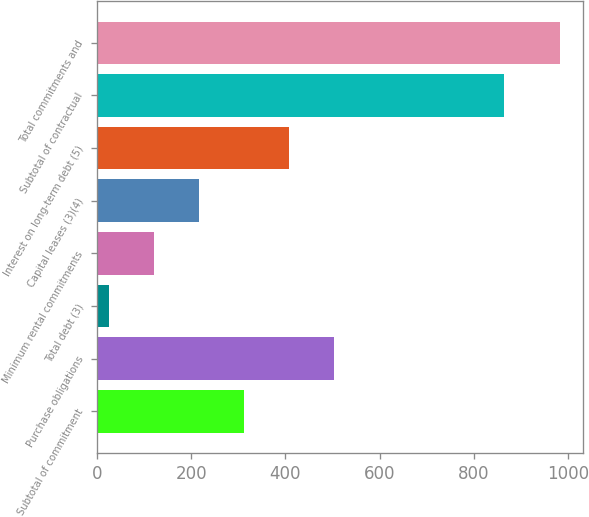Convert chart to OTSL. <chart><loc_0><loc_0><loc_500><loc_500><bar_chart><fcel>Subtotal of commitment<fcel>Purchase obligations<fcel>Total debt (3)<fcel>Minimum rental commitments<fcel>Capital leases (3)(4)<fcel>Interest on long-term debt (5)<fcel>Subtotal of contractual<fcel>Total commitments and<nl><fcel>312.1<fcel>503.5<fcel>25<fcel>120.7<fcel>216.4<fcel>407.8<fcel>864<fcel>982<nl></chart> 